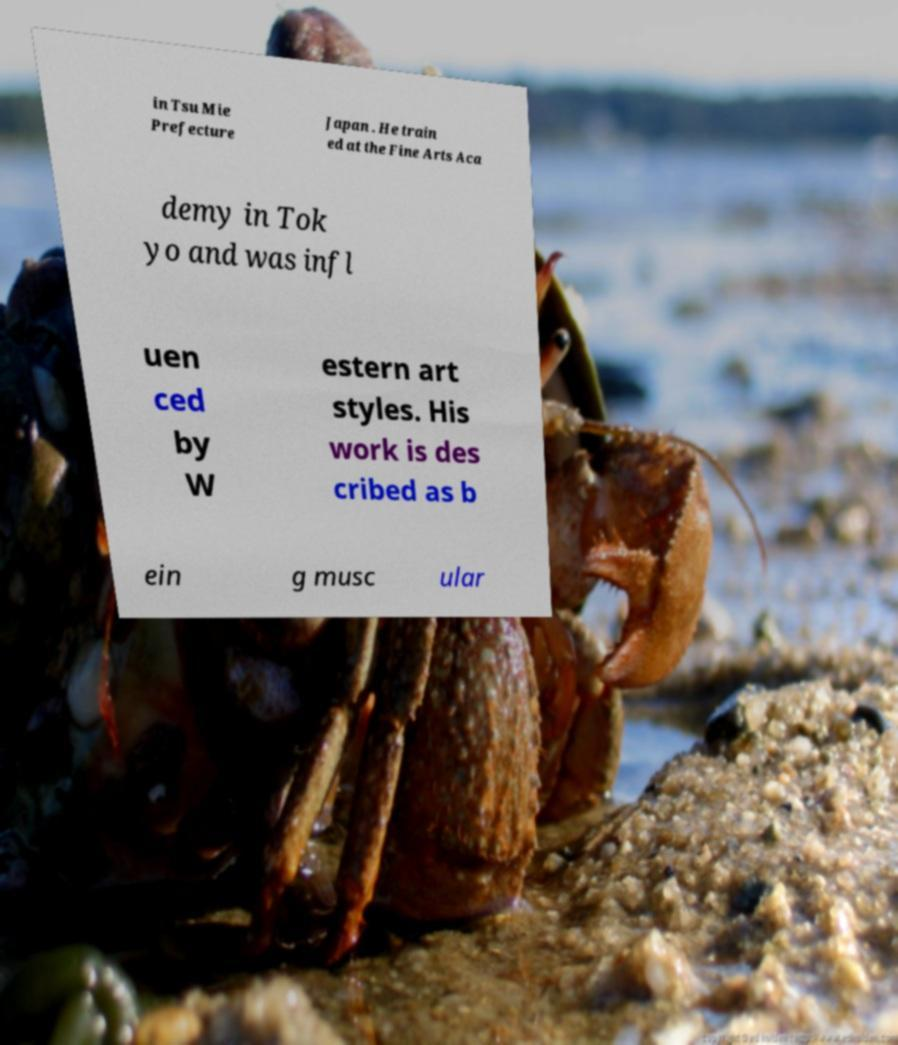Could you assist in decoding the text presented in this image and type it out clearly? in Tsu Mie Prefecture Japan . He train ed at the Fine Arts Aca demy in Tok yo and was infl uen ced by W estern art styles. His work is des cribed as b ein g musc ular 